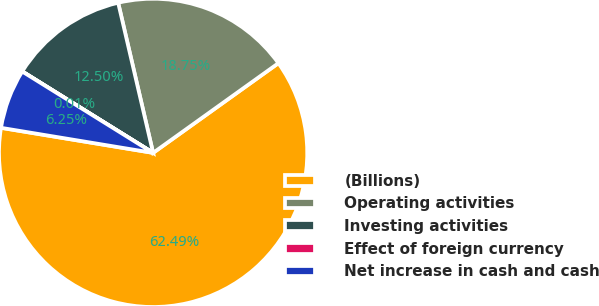Convert chart. <chart><loc_0><loc_0><loc_500><loc_500><pie_chart><fcel>(Billions)<fcel>Operating activities<fcel>Investing activities<fcel>Effect of foreign currency<fcel>Net increase in cash and cash<nl><fcel>62.49%<fcel>18.75%<fcel>12.5%<fcel>0.01%<fcel>6.25%<nl></chart> 